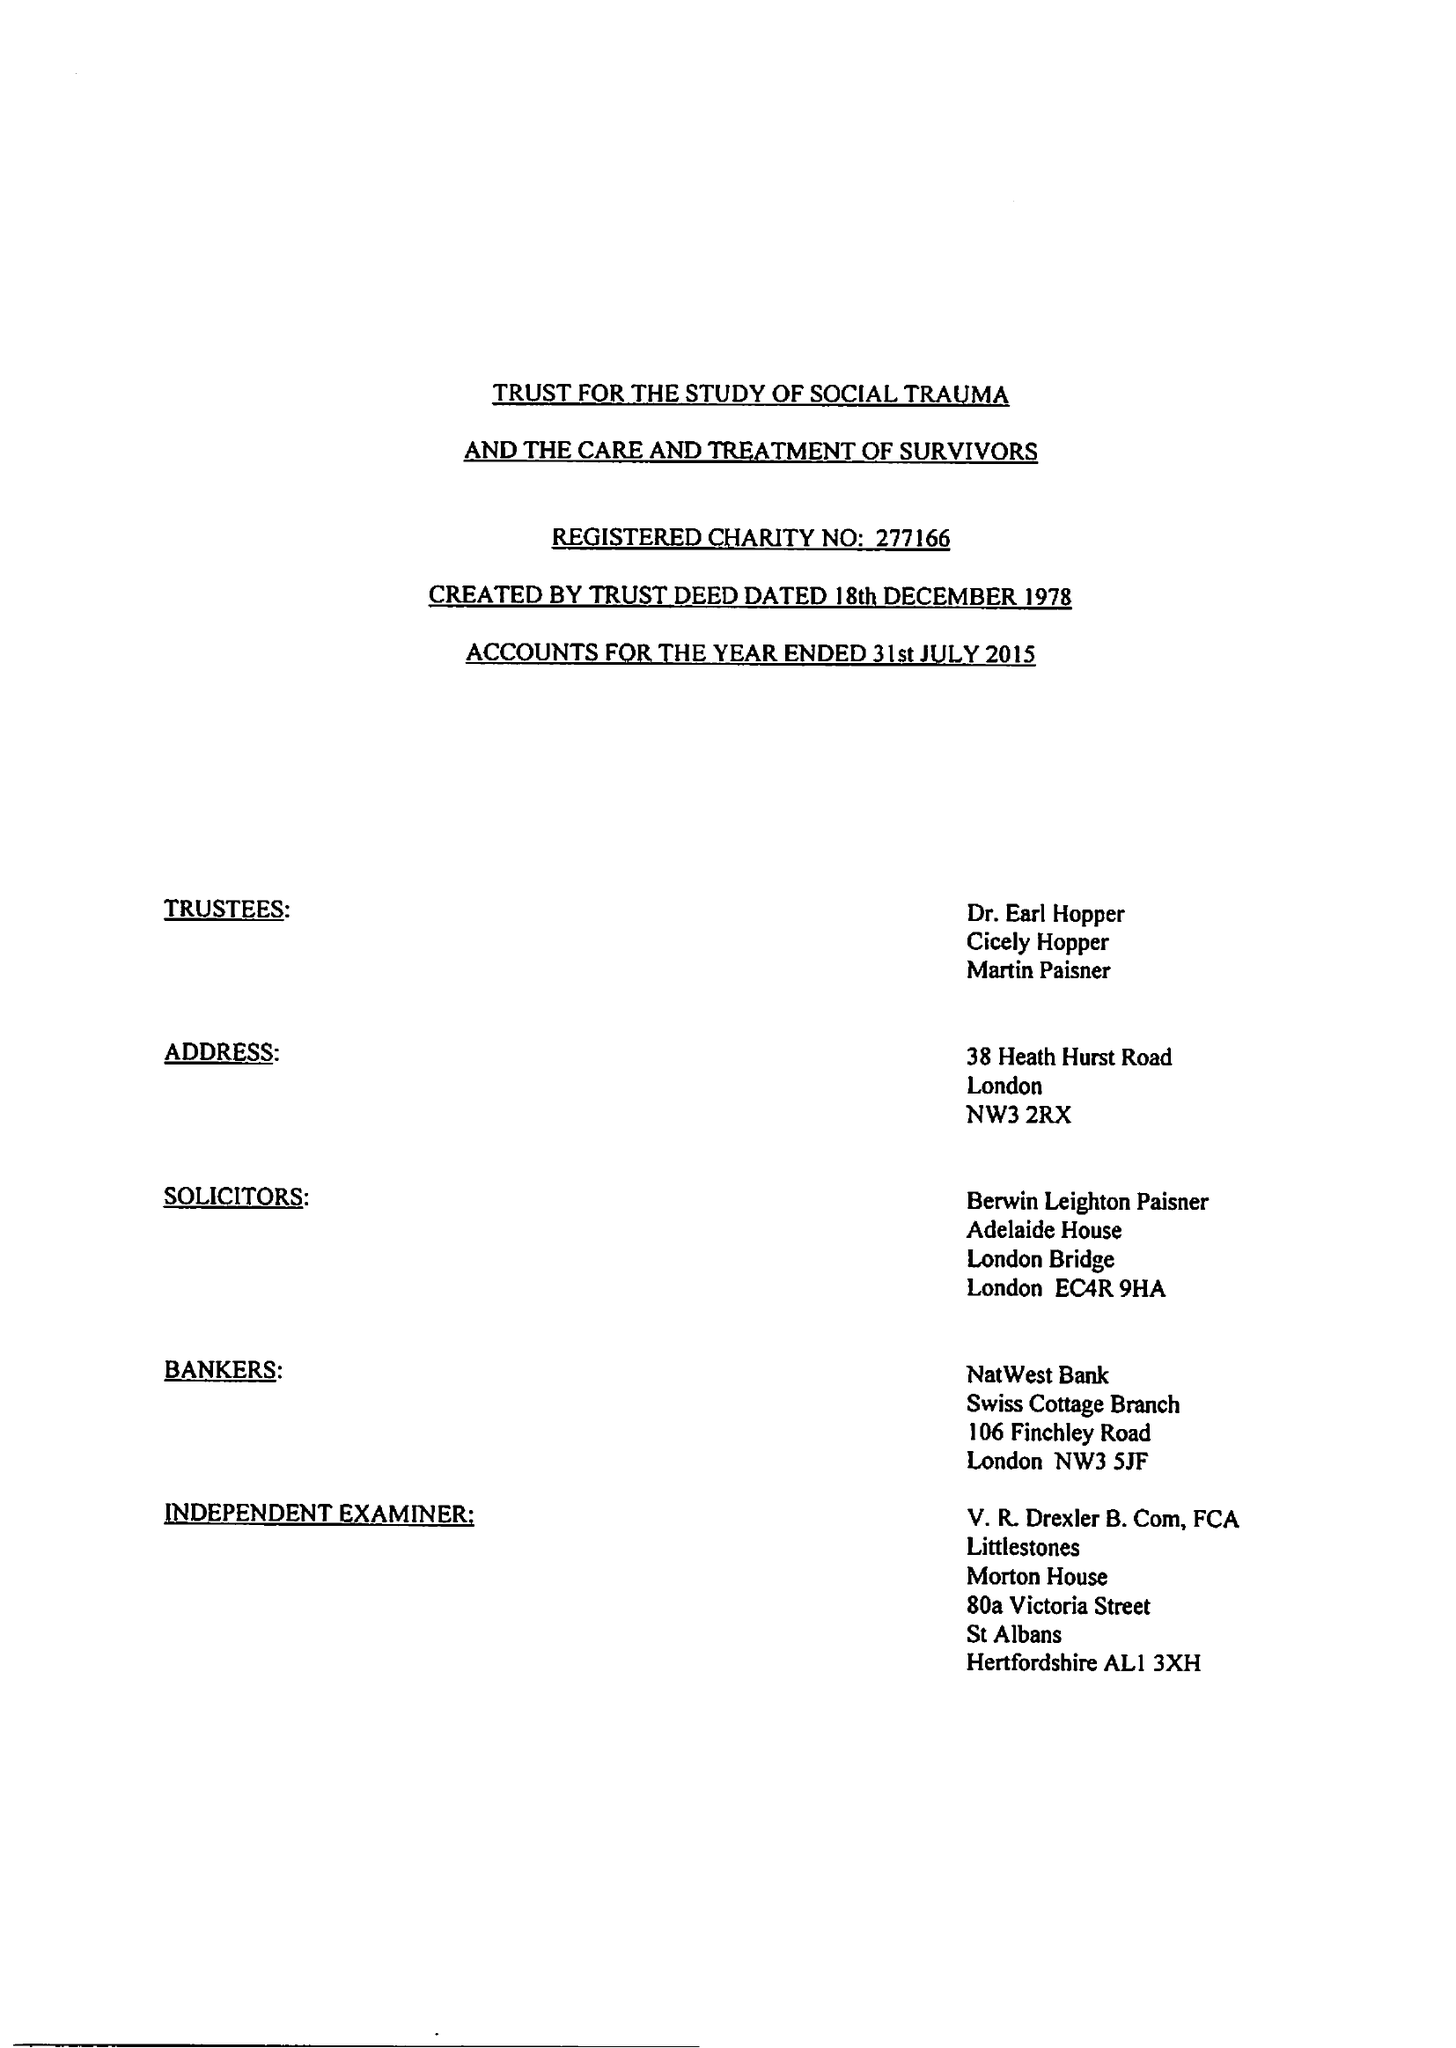What is the value for the address__street_line?
Answer the question using a single word or phrase. 80A VICTORIA STREET 